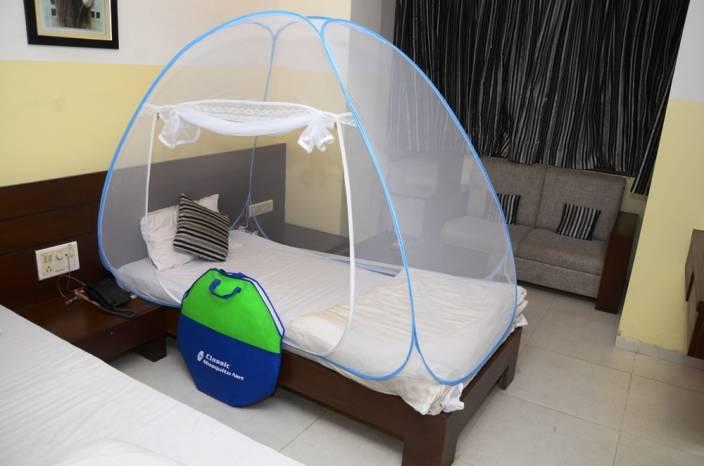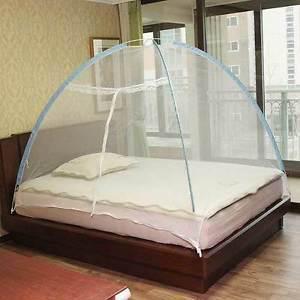The first image is the image on the left, the second image is the image on the right. For the images shown, is this caption "The left image shows a dome canopy with an open side." true? Answer yes or no. Yes. 